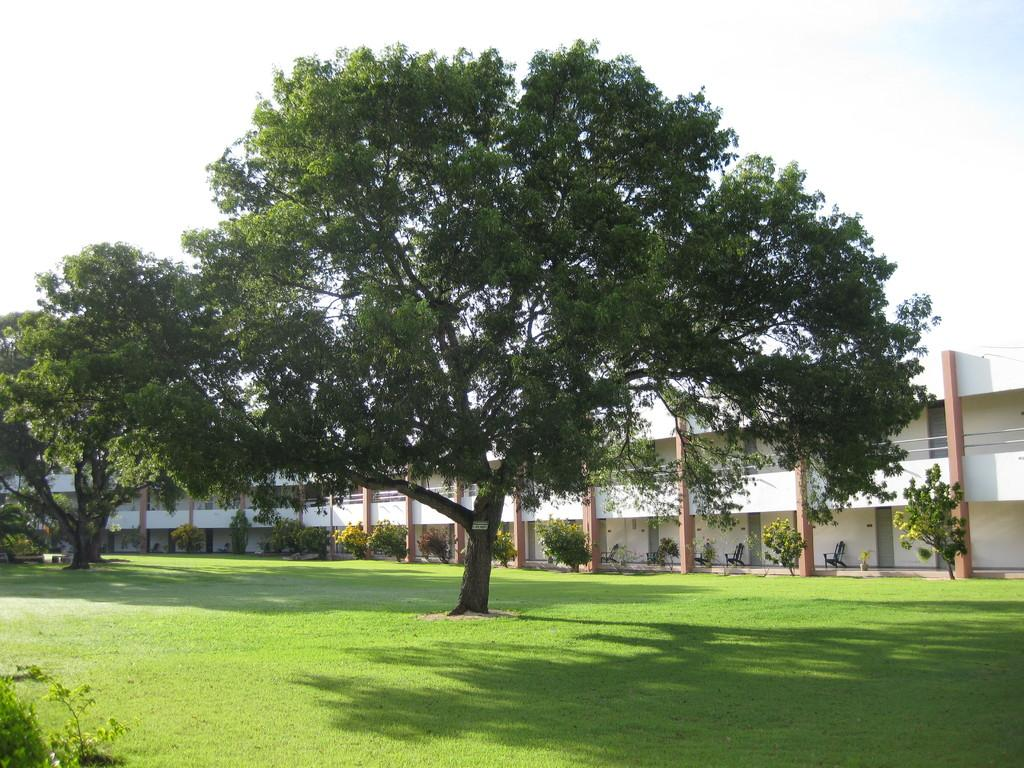What type of vegetation is in the foreground of the image? There is green grass in the foreground of the image. What else can be seen in the image besides the grass? There are trees visible in the image. Where is the building located in the image? The building is on the right side of the image. What is visible in the sky in the image? Clouds are present in the sky in the image. How many quinces are hanging from the trees in the image? There are no quinces visible in the image; only trees are present. What type of fruit is being used as an afterthought in the image? There is no fruit or afterthought present in the image. 